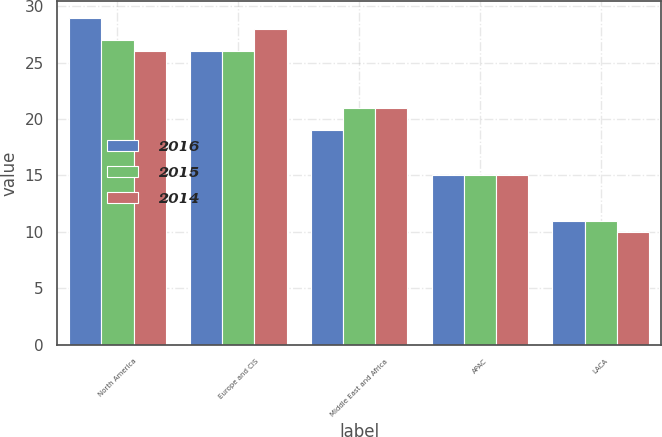Convert chart. <chart><loc_0><loc_0><loc_500><loc_500><stacked_bar_chart><ecel><fcel>North America<fcel>Europe and CIS<fcel>Middle East and Africa<fcel>APAC<fcel>LACA<nl><fcel>2016<fcel>29<fcel>26<fcel>19<fcel>15<fcel>11<nl><fcel>2015<fcel>27<fcel>26<fcel>21<fcel>15<fcel>11<nl><fcel>2014<fcel>26<fcel>28<fcel>21<fcel>15<fcel>10<nl></chart> 